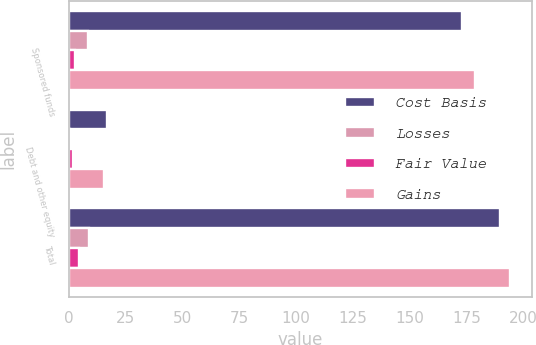Convert chart to OTSL. <chart><loc_0><loc_0><loc_500><loc_500><stacked_bar_chart><ecel><fcel>Sponsored funds<fcel>Debt and other equity<fcel>Total<nl><fcel>Cost Basis<fcel>172.9<fcel>16.8<fcel>189.7<nl><fcel>Losses<fcel>8.3<fcel>0.5<fcel>8.8<nl><fcel>Fair Value<fcel>2.6<fcel>1.8<fcel>4.4<nl><fcel>Gains<fcel>178.6<fcel>15.5<fcel>194.1<nl></chart> 